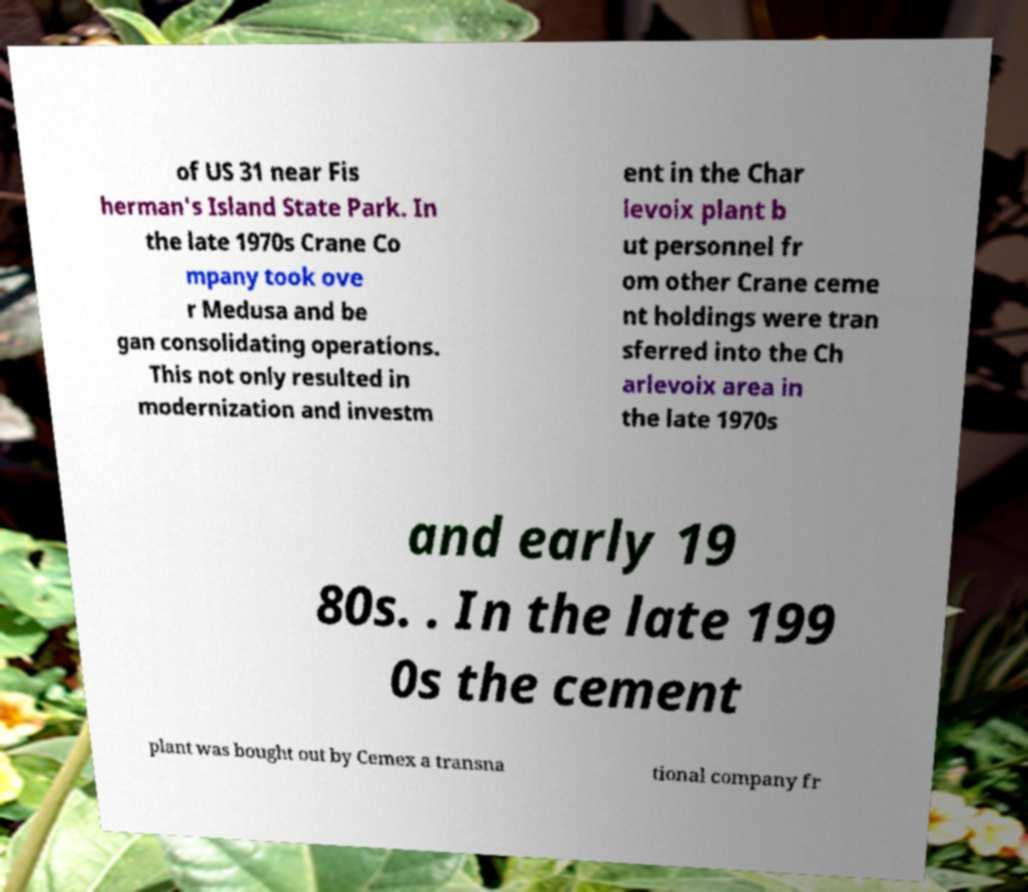Can you read and provide the text displayed in the image?This photo seems to have some interesting text. Can you extract and type it out for me? of US 31 near Fis herman's Island State Park. In the late 1970s Crane Co mpany took ove r Medusa and be gan consolidating operations. This not only resulted in modernization and investm ent in the Char levoix plant b ut personnel fr om other Crane ceme nt holdings were tran sferred into the Ch arlevoix area in the late 1970s and early 19 80s. . In the late 199 0s the cement plant was bought out by Cemex a transna tional company fr 